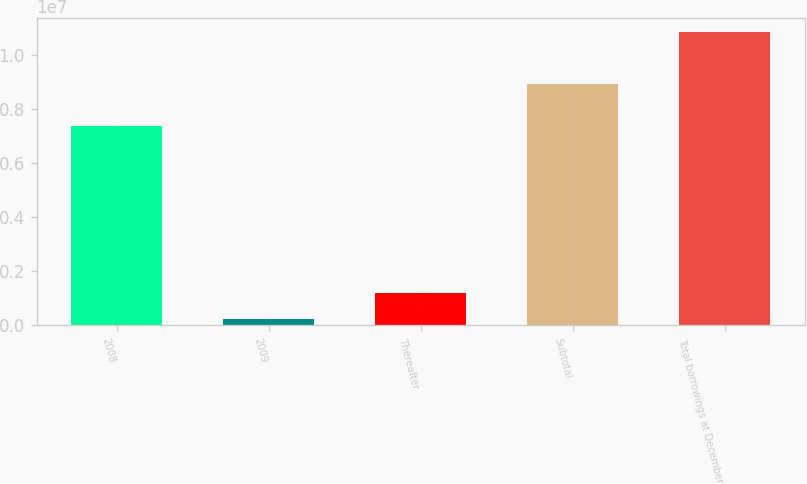Convert chart. <chart><loc_0><loc_0><loc_500><loc_500><bar_chart><fcel>2008<fcel>2009<fcel>Thereafter<fcel>Subtotal<fcel>Total borrowings at December<nl><fcel>7.37403e+06<fcel>251151<fcel>1.20713e+06<fcel>8.93269e+06<fcel>1.08409e+07<nl></chart> 